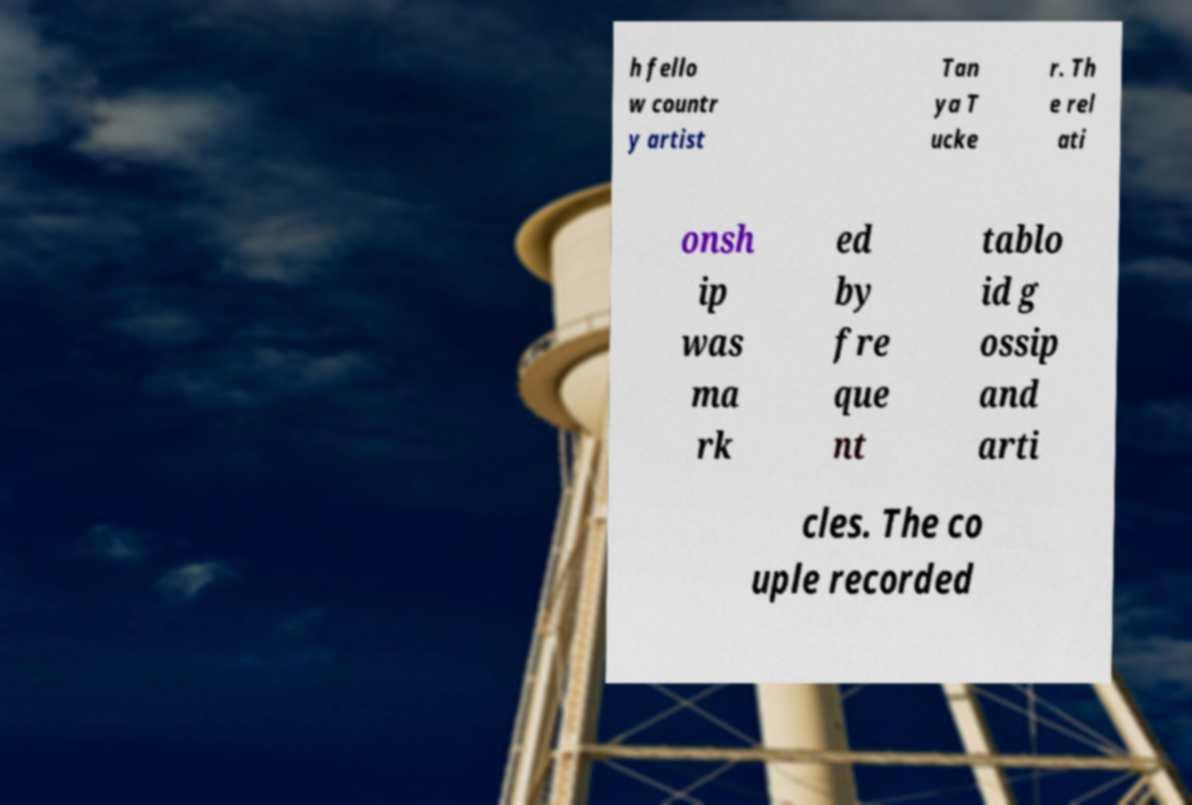Could you extract and type out the text from this image? h fello w countr y artist Tan ya T ucke r. Th e rel ati onsh ip was ma rk ed by fre que nt tablo id g ossip and arti cles. The co uple recorded 